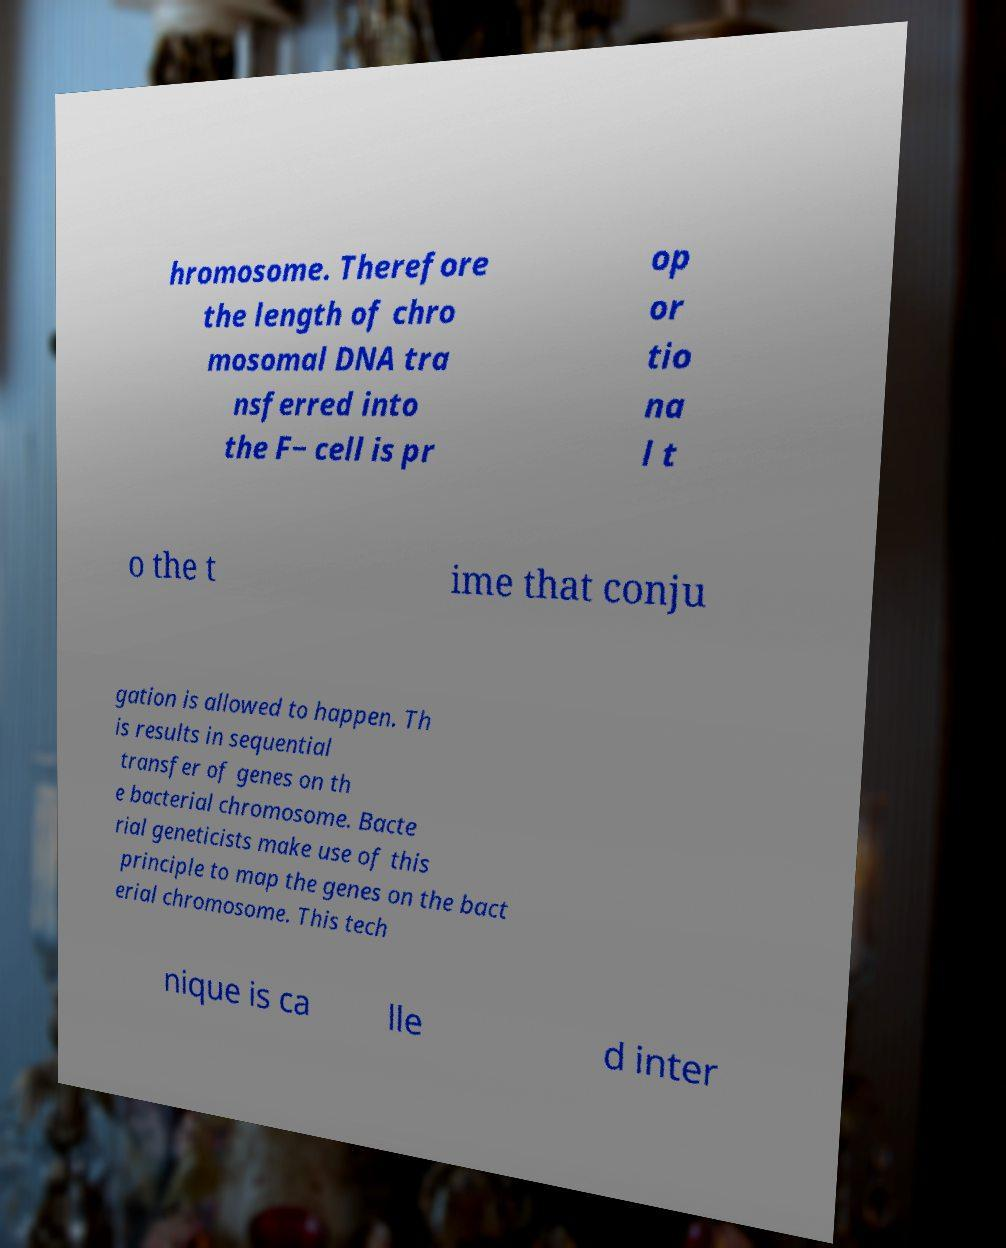Please read and relay the text visible in this image. What does it say? hromosome. Therefore the length of chro mosomal DNA tra nsferred into the F− cell is pr op or tio na l t o the t ime that conju gation is allowed to happen. Th is results in sequential transfer of genes on th e bacterial chromosome. Bacte rial geneticists make use of this principle to map the genes on the bact erial chromosome. This tech nique is ca lle d inter 